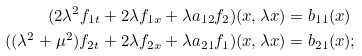<formula> <loc_0><loc_0><loc_500><loc_500>( 2 \lambda ^ { 2 } f _ { 1 t } + 2 \lambda f _ { 1 x } + \lambda a _ { 1 2 } f _ { 2 } ) ( x , \lambda x ) & = b _ { 1 1 } ( x ) \\ ( ( \lambda ^ { 2 } + \mu ^ { 2 } ) f _ { 2 t } + 2 \lambda f _ { 2 x } + \lambda a _ { 2 1 } f _ { 1 } ) ( x , \lambda x ) & = b _ { 2 1 } ( x ) ;</formula> 